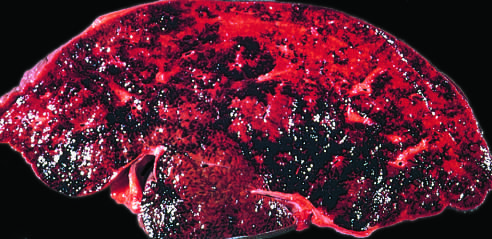has the white circles caused severe hepatic congestion?
Answer the question using a single word or phrase. No 